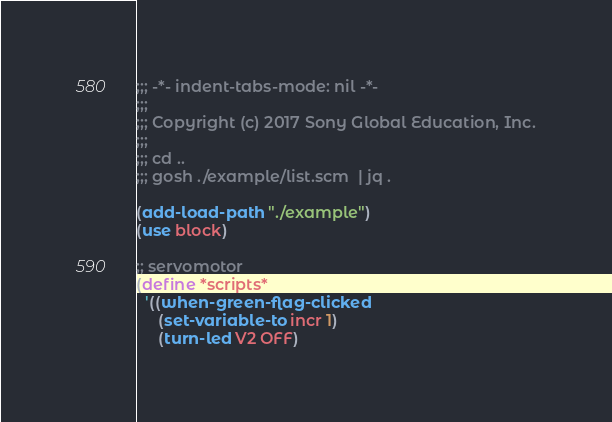Convert code to text. <code><loc_0><loc_0><loc_500><loc_500><_Scheme_>;;; -*- indent-tabs-mode: nil -*-
;;;
;;; Copyright (c) 2017 Sony Global Education, Inc.
;;;
;;; cd ..
;;; gosh ./example/list.scm  | jq .

(add-load-path "./example")
(use block)

;; servomotor
(define *scripts*
  '((when-green-flag-clicked
     (set-variable-to incr 1)
     (turn-led V2 OFF)</code> 